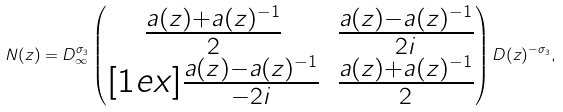Convert formula to latex. <formula><loc_0><loc_0><loc_500><loc_500>N ( z ) = D _ { \infty } ^ { \sigma _ { 3 } } \begin{pmatrix} \frac { a ( z ) + a ( z ) ^ { - 1 } } { 2 } & \frac { a ( z ) - a ( z ) ^ { - 1 } } { 2 i } \\ [ 1 e x ] \frac { a ( z ) - a ( z ) ^ { - 1 } } { - 2 i } & \frac { a ( z ) + a ( z ) ^ { - 1 } } { 2 } \end{pmatrix} D ( z ) ^ { - \sigma _ { 3 } } ,</formula> 